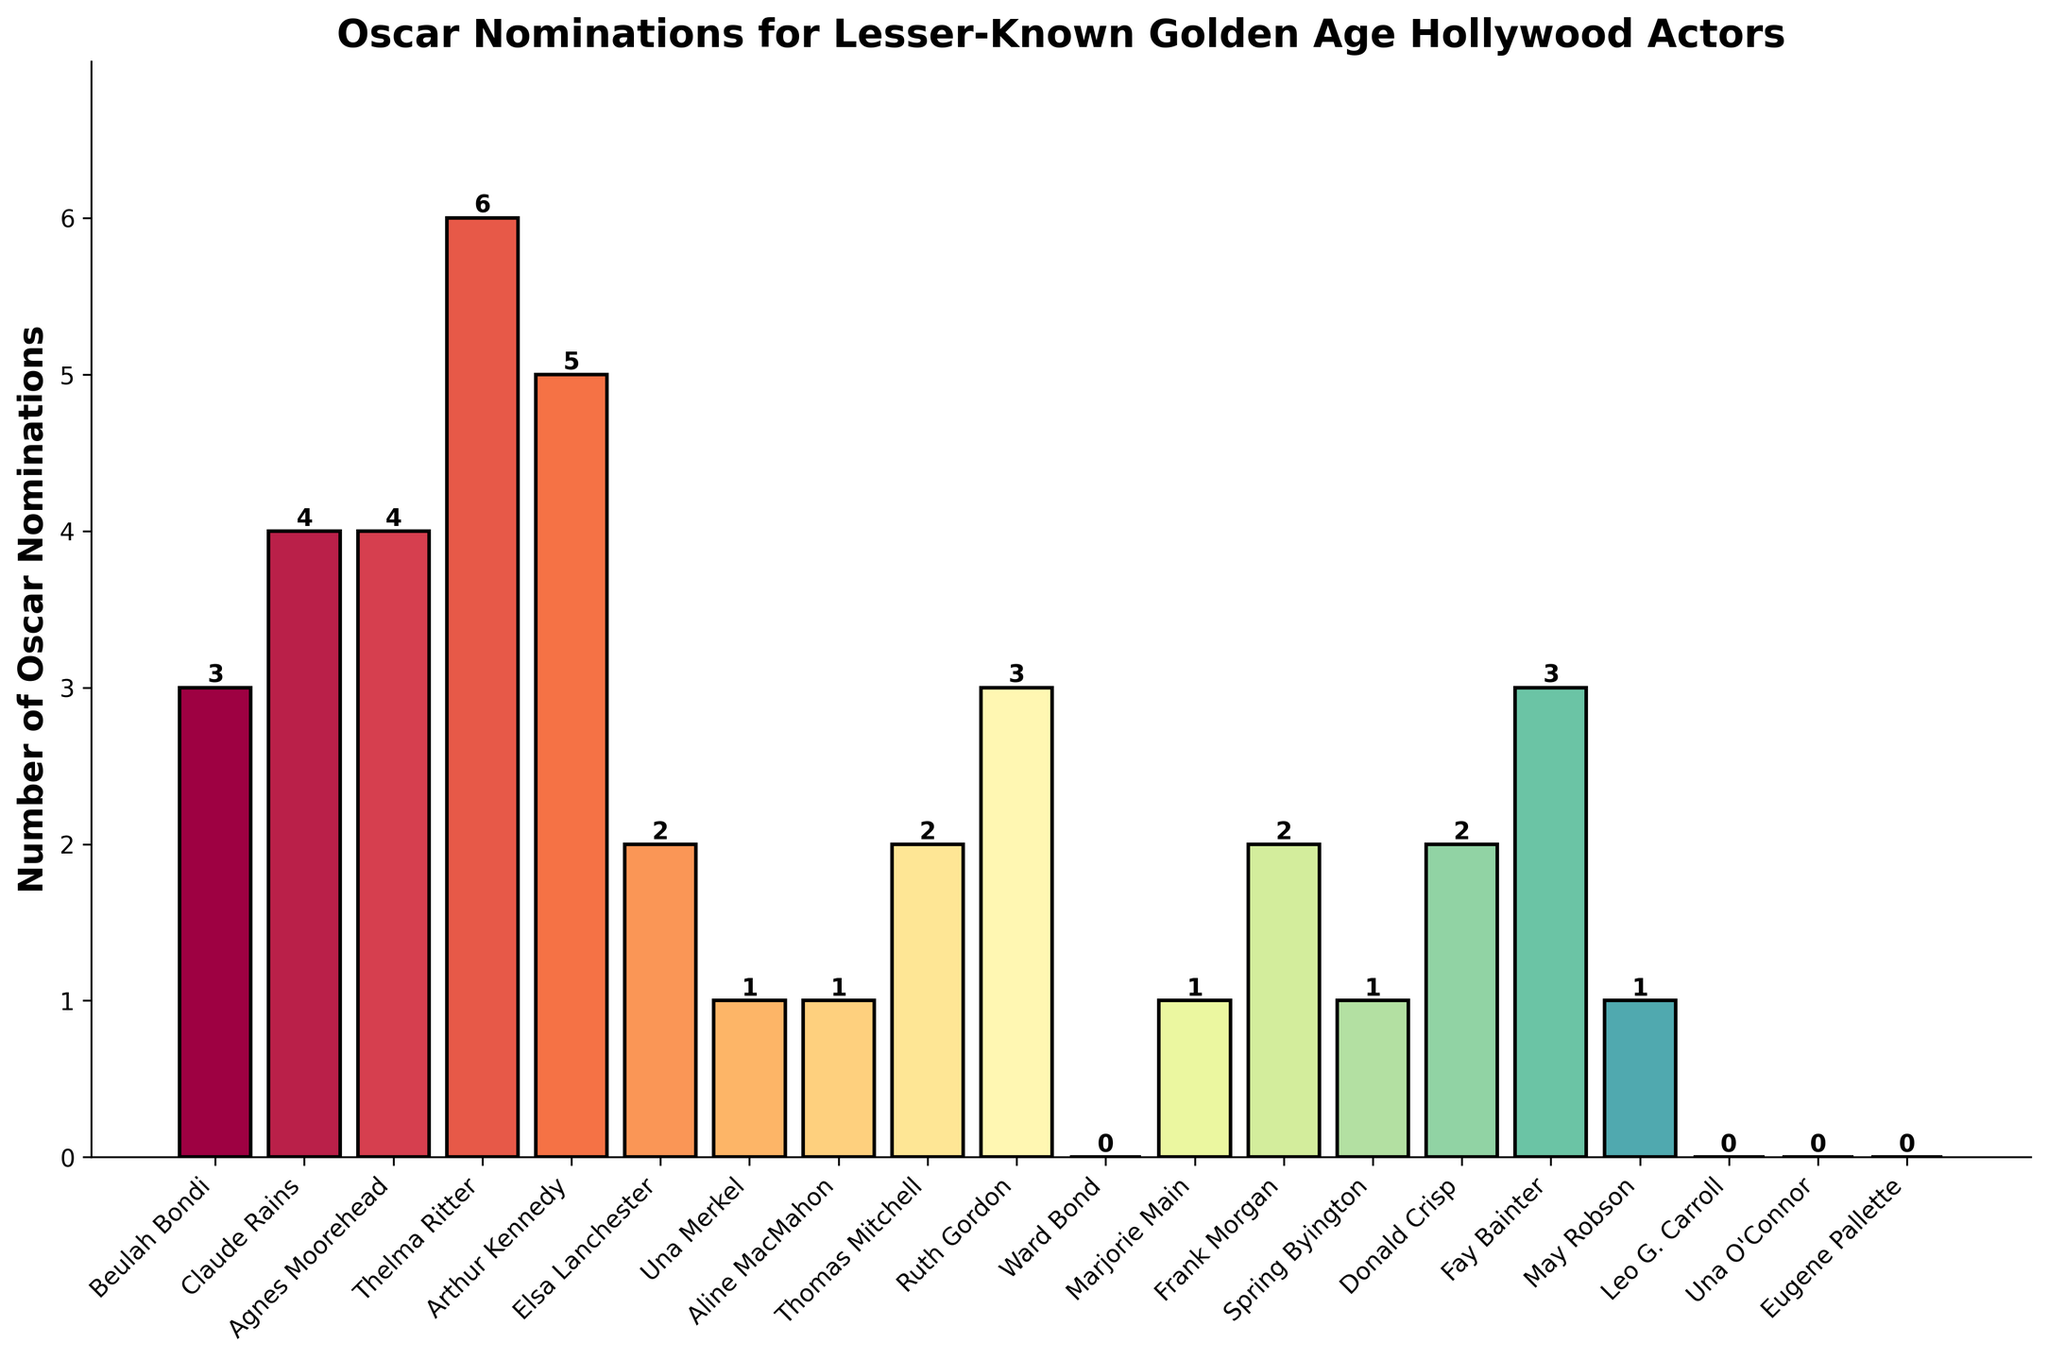Which actor has received the most Oscar nominations? Thelma Ritter has the highest number of nominations.
Answer: Thelma Ritter How many actors have received exactly 2 Oscar nominations? By counting the bars reaching 2 on the y-axis, we find Elsa Lanchester, Thomas Mitchell, Frank Morgan, and Donald Crisp.
Answer: 4 What's the total number of Oscar nominations for all actors listed? Summing all the nominations: 3+4+4+6+5+2+1+1+2+3+0+1+2+1+2+3+1+0+0+0 = 41.
Answer: 41 How many more nominations does Thelma Ritter have than Marjorie Main? Thelma Ritter has 6, Marjorie Main has 1. The difference is 6 - 1.
Answer: 5 Which actor or actress received the least number of nominations? Ward Bond, Leo G. Carroll, Una O'Connor, and Eugene Pallette all received 0 nominations.
Answer: 4 actors/actresses with 0 Who has more nominations, Claude Rains or Arthur Kennedy? Claude Rains has 4 nominations, Arthur Kennedy has 5. Arthur Kennedy has more.
Answer: Arthur Kennedy Which nomination counts are shared by the most actors? The counts of 0 and 1 nominations are shared by 4 actors each.
Answer: 0 and 1 nominations What's the average number of nominations received by all listed actors and actresses? Sum of nominations is 41. There are 20 actors/actresses: 41/20 = 2.05.
Answer: 2.05 What is the difference between the highest and lowest number of nominations? The highest number is 6 (Thelma Ritter), the lowest is 0. Difference is 6 - 0.
Answer: 6 